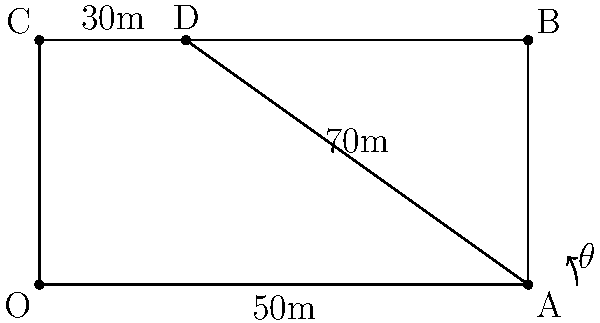In a youth football match, you're instructing a player on how to take a corner kick. The goal is to aim for a teammate positioned at point D, 30 meters from the corner flag. Given that the width of the field is 50 meters and the length is 100 meters, what is the optimal angle $\theta$ (in degrees, rounded to the nearest whole number) for the corner kick from point A to reach point D? To find the optimal angle for the corner kick, we need to use trigonometry. Let's break it down step-by-step:

1. Identify the right triangle:
   - The corner flag is at point A
   - The target player is at point D
   - This forms a right triangle ACD

2. We know two sides of this triangle:
   - AD (adjacent to angle $\theta$) = 70m (100m - 30m)
   - CD (opposite to angle $\theta$) = 50m

3. To find angle $\theta$, we need to use the arctangent function:
   
   $\theta = \arctan(\frac{\text{opposite}}{\text{adjacent}})$

4. Plugging in our values:
   
   $\theta = \arctan(\frac{50}{70})$

5. Calculate:
   
   $\theta = \arctan(0.7142857...)$
   
   $\theta \approx 35.5377...$

6. Rounding to the nearest whole number:
   
   $\theta \approx 36°$

Therefore, the optimal angle for the corner kick is approximately 36 degrees.
Answer: 36° 